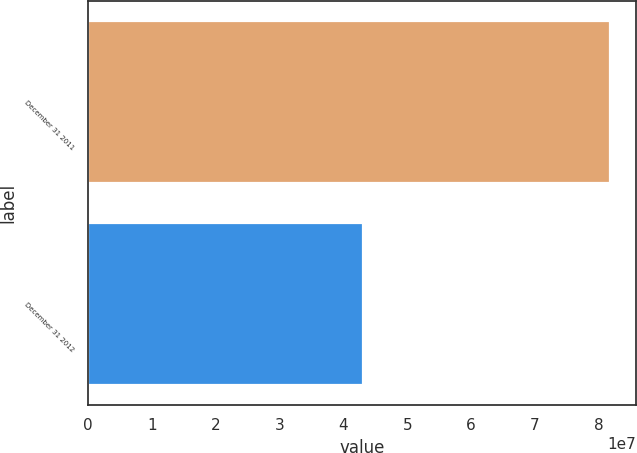<chart> <loc_0><loc_0><loc_500><loc_500><bar_chart><fcel>December 31 2011<fcel>December 31 2012<nl><fcel>8.17345e+07<fcel>4.30521e+07<nl></chart> 